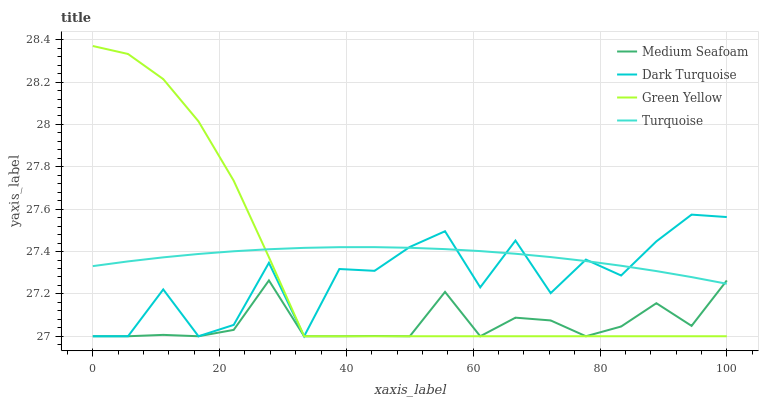Does Medium Seafoam have the minimum area under the curve?
Answer yes or no. Yes. Does Turquoise have the maximum area under the curve?
Answer yes or no. Yes. Does Green Yellow have the minimum area under the curve?
Answer yes or no. No. Does Green Yellow have the maximum area under the curve?
Answer yes or no. No. Is Turquoise the smoothest?
Answer yes or no. Yes. Is Dark Turquoise the roughest?
Answer yes or no. Yes. Is Green Yellow the smoothest?
Answer yes or no. No. Is Green Yellow the roughest?
Answer yes or no. No. Does Dark Turquoise have the lowest value?
Answer yes or no. Yes. Does Turquoise have the lowest value?
Answer yes or no. No. Does Green Yellow have the highest value?
Answer yes or no. Yes. Does Turquoise have the highest value?
Answer yes or no. No. Does Medium Seafoam intersect Turquoise?
Answer yes or no. Yes. Is Medium Seafoam less than Turquoise?
Answer yes or no. No. Is Medium Seafoam greater than Turquoise?
Answer yes or no. No. 